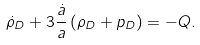<formula> <loc_0><loc_0><loc_500><loc_500>\dot { \rho } _ { D } + 3 \frac { \dot { a } } { a } \left ( \rho _ { D } + p _ { D } \right ) = - Q .</formula> 